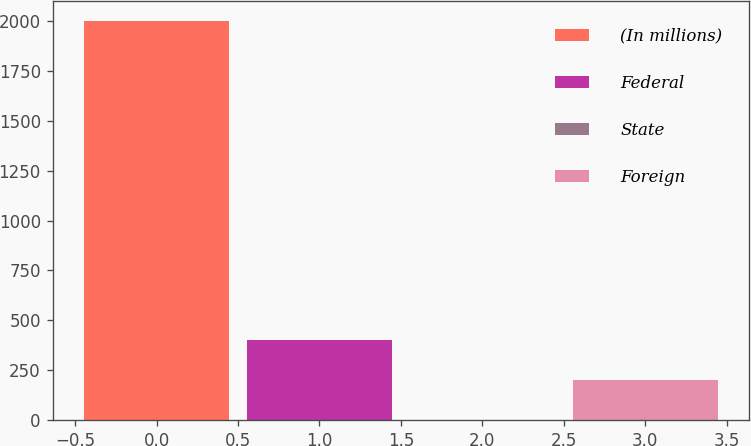Convert chart. <chart><loc_0><loc_0><loc_500><loc_500><bar_chart><fcel>(In millions)<fcel>Federal<fcel>State<fcel>Foreign<nl><fcel>2000<fcel>402.32<fcel>2.9<fcel>202.61<nl></chart> 